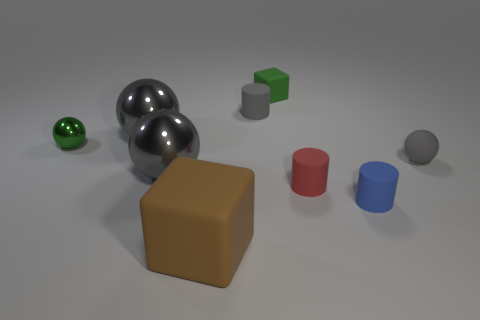Subtract all gray spheres. How many were subtracted if there are1gray spheres left? 2 Subtract all red blocks. How many gray spheres are left? 3 Subtract 1 balls. How many balls are left? 3 Add 1 brown blocks. How many objects exist? 10 Subtract all cylinders. How many objects are left? 6 Add 9 gray metallic cubes. How many gray metallic cubes exist? 9 Subtract 0 cyan cylinders. How many objects are left? 9 Subtract all small green rubber blocks. Subtract all large balls. How many objects are left? 6 Add 8 tiny red matte objects. How many tiny red matte objects are left? 9 